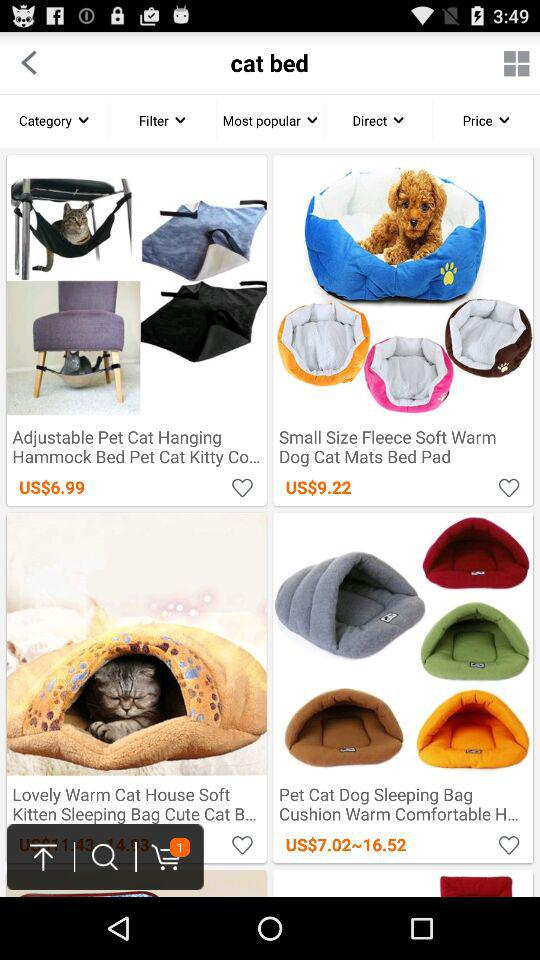How much is the "Lovely Warm Cat House Soft Kitten Sleeping Bag Cute Cat B..."?
When the provided information is insufficient, respond with <no answer>. <no answer> 